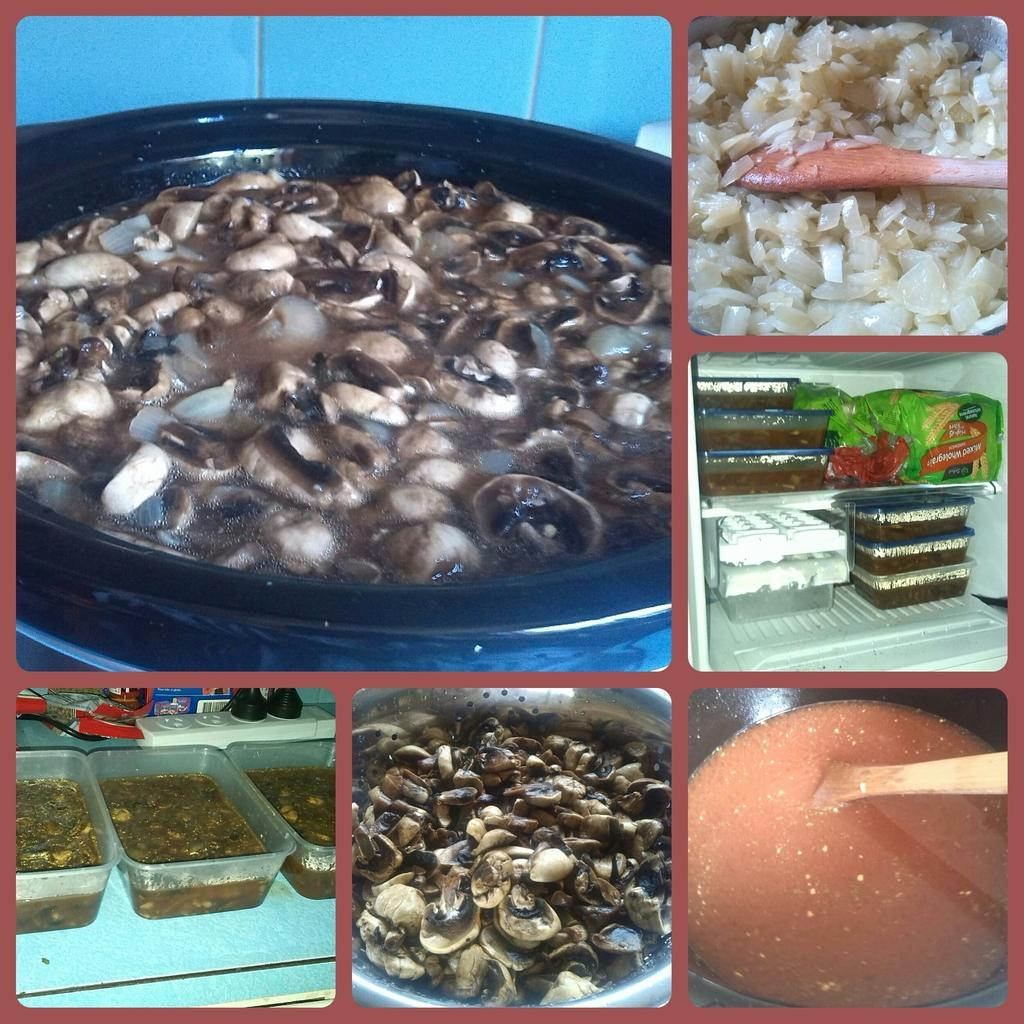What type of image is being described? The image is a photo collage. What can be found within the collage? There are food items in the collage. How are the food items presented in the collage? The food items are in different bowls. What yard is visible in the photo collage? There is no yard visible in the photo collage; it features food items in different bowls. What cause is being promoted in the photo collage? There is no cause being promoted in the photo collage; it simply displays food items in different bowls. 